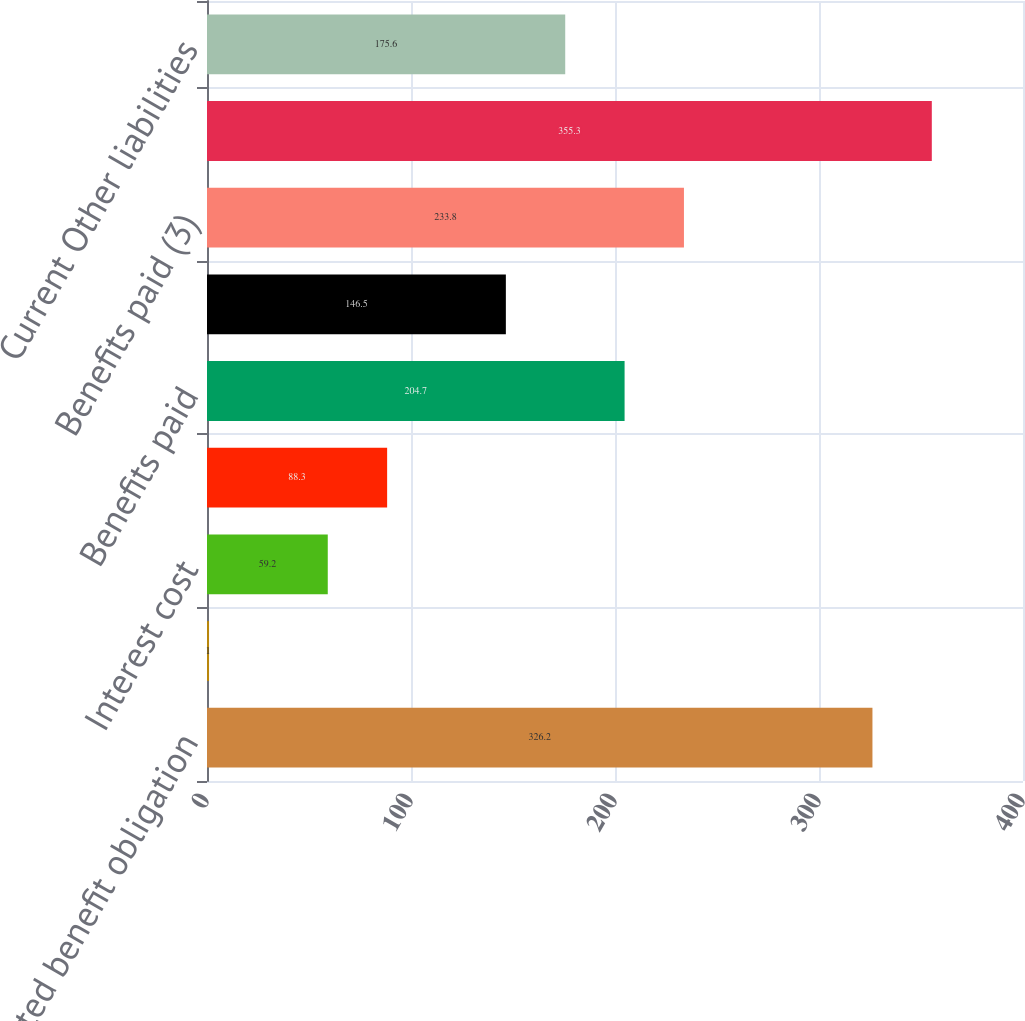<chart> <loc_0><loc_0><loc_500><loc_500><bar_chart><fcel>Projected benefit obligation<fcel>Service cost<fcel>Interest cost<fcel>Net actuarial (gain) loss (1)<fcel>Benefits paid<fcel>Employer contributions<fcel>Benefits paid (3)<fcel>Funded Status as of end of<fcel>Current Other liabilities<nl><fcel>326.2<fcel>1<fcel>59.2<fcel>88.3<fcel>204.7<fcel>146.5<fcel>233.8<fcel>355.3<fcel>175.6<nl></chart> 